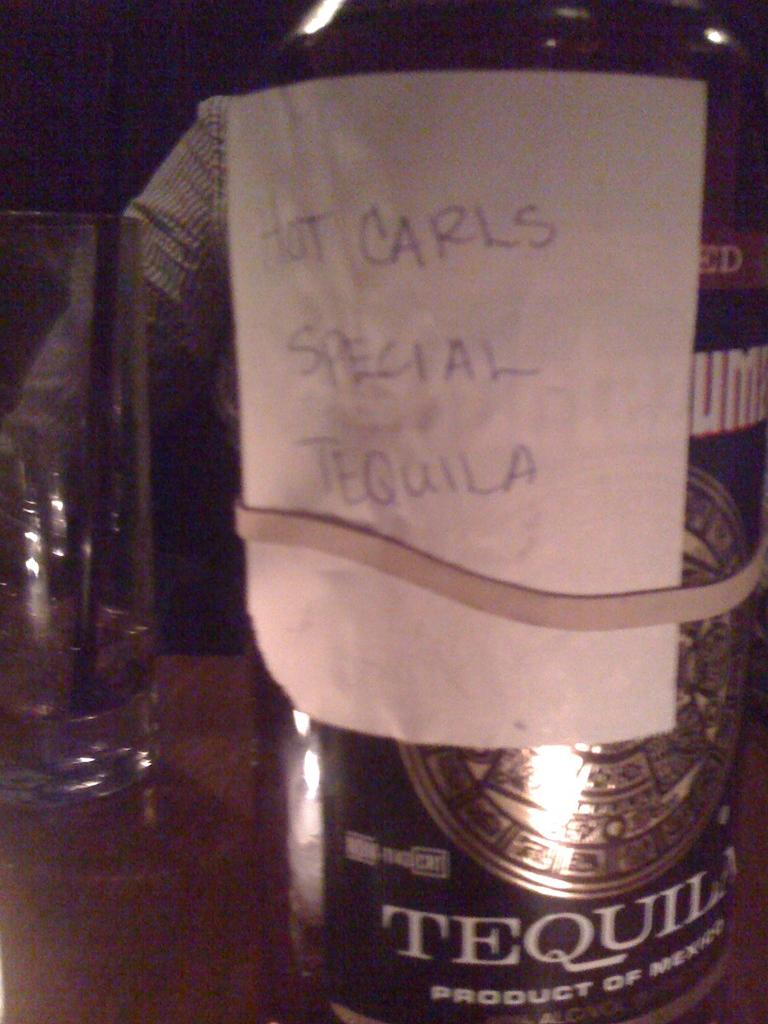<image>
Write a terse but informative summary of the picture. The note rubber banded around the tequila bottle says it is not Carl's special tequila. 